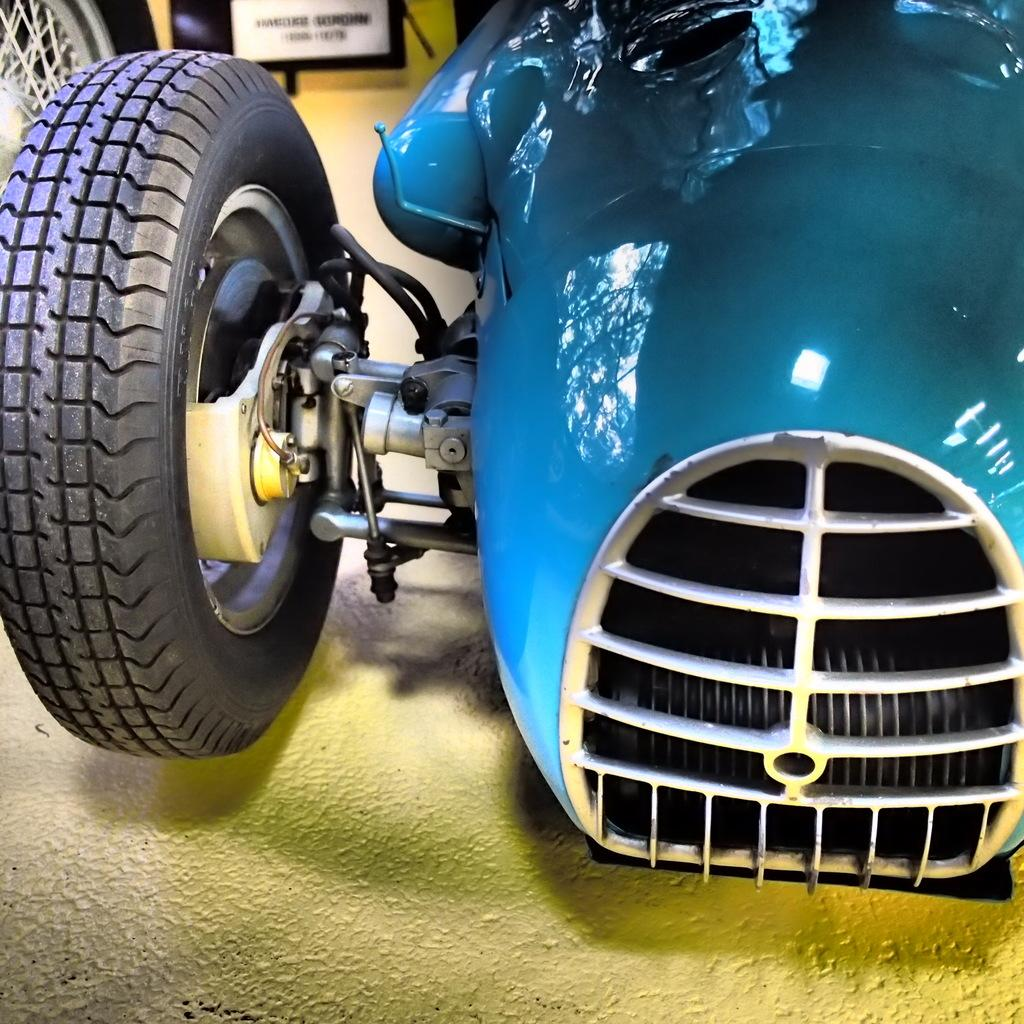What is the main subject of the image? There is a vehicle in the image. What is the surface on which the vehicle is placed? There is a floor at the bottom of the image. What can be seen in the background of the image? There is a board with text in the background of the image. How many giraffes are visible in the image? There are no giraffes present in the image. What type of disease can be seen affecting the vehicle in the image? There is no disease affecting the vehicle in the image; it appears to be in good condition. 